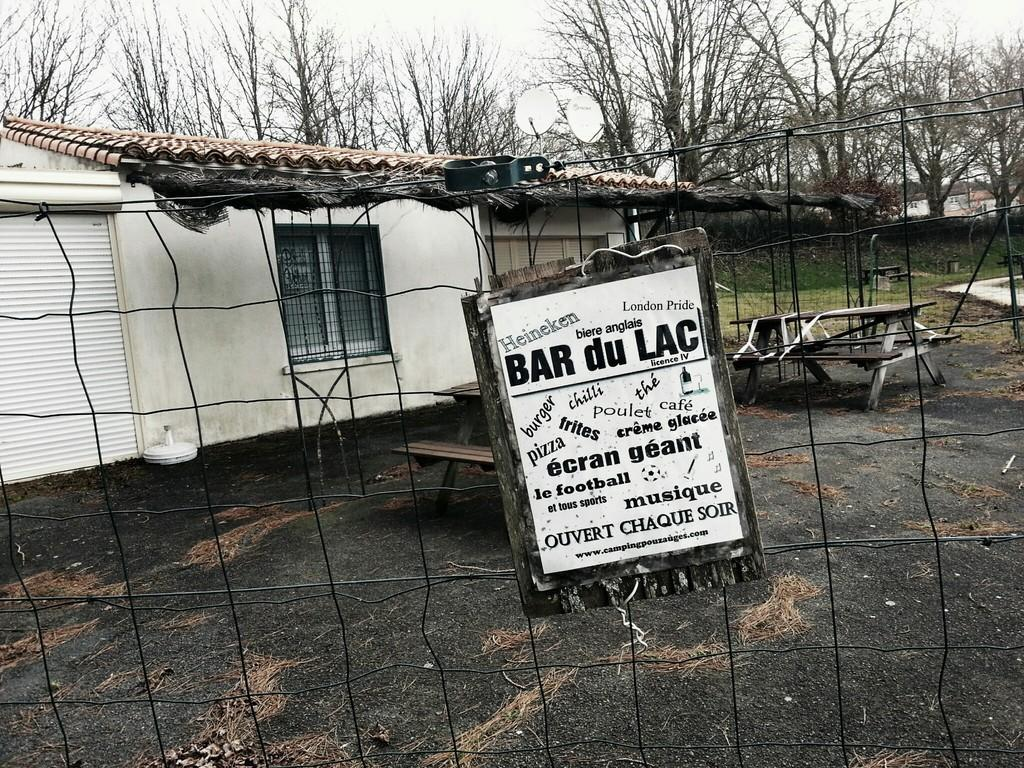<image>
Give a short and clear explanation of the subsequent image. An old, run down, white, fenced in building has a sign on a dry rotted piece of wood advertising things like burgers, pizza, and beer. 